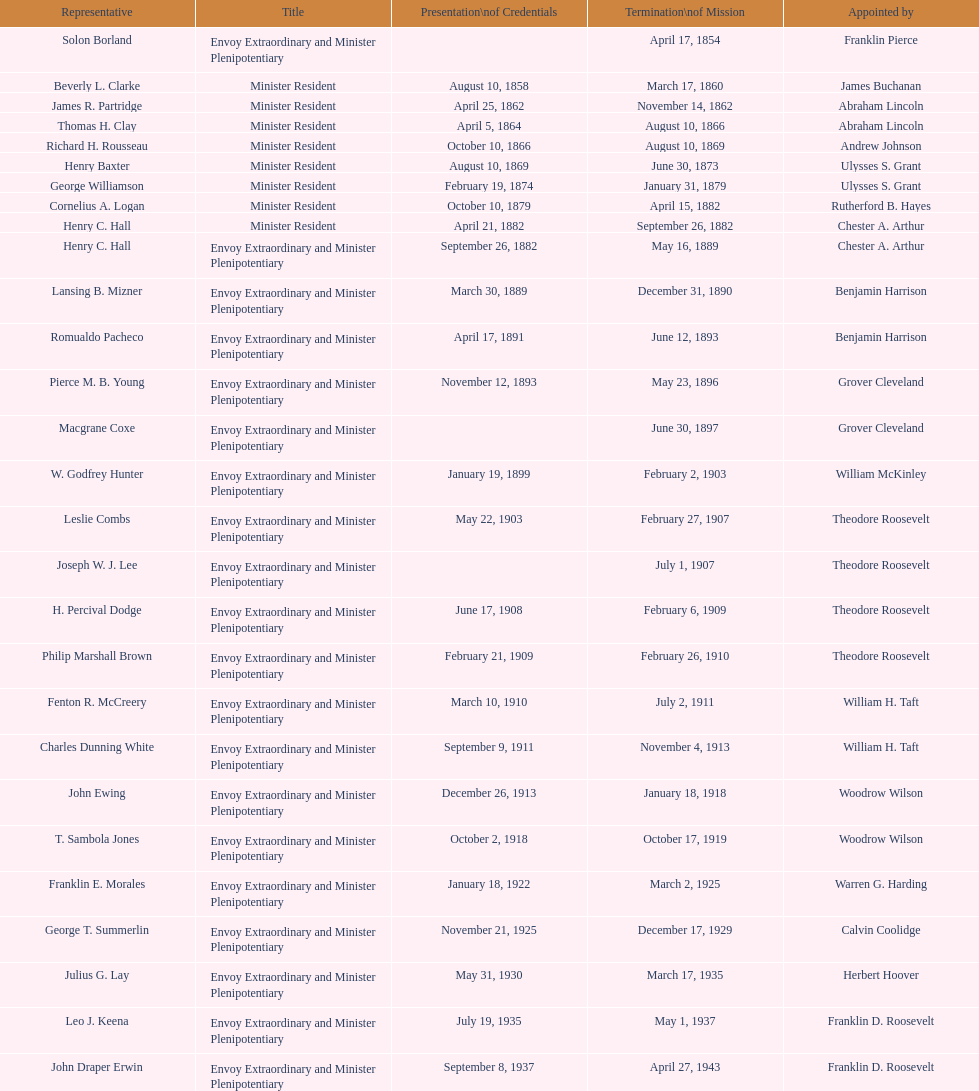Which representatives were exclusively appointed by franklin pierce? Solon Borland. 